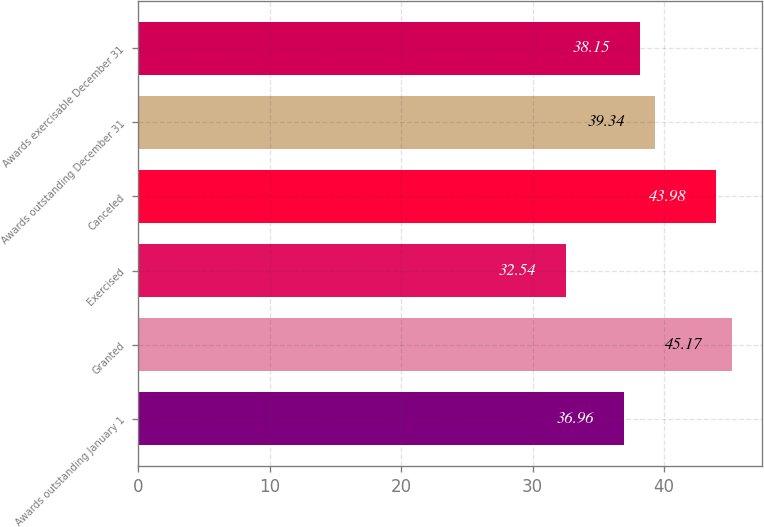Convert chart. <chart><loc_0><loc_0><loc_500><loc_500><bar_chart><fcel>Awards outstanding January 1<fcel>Granted<fcel>Exercised<fcel>Canceled<fcel>Awards outstanding December 31<fcel>Awards exercisable December 31<nl><fcel>36.96<fcel>45.17<fcel>32.54<fcel>43.98<fcel>39.34<fcel>38.15<nl></chart> 